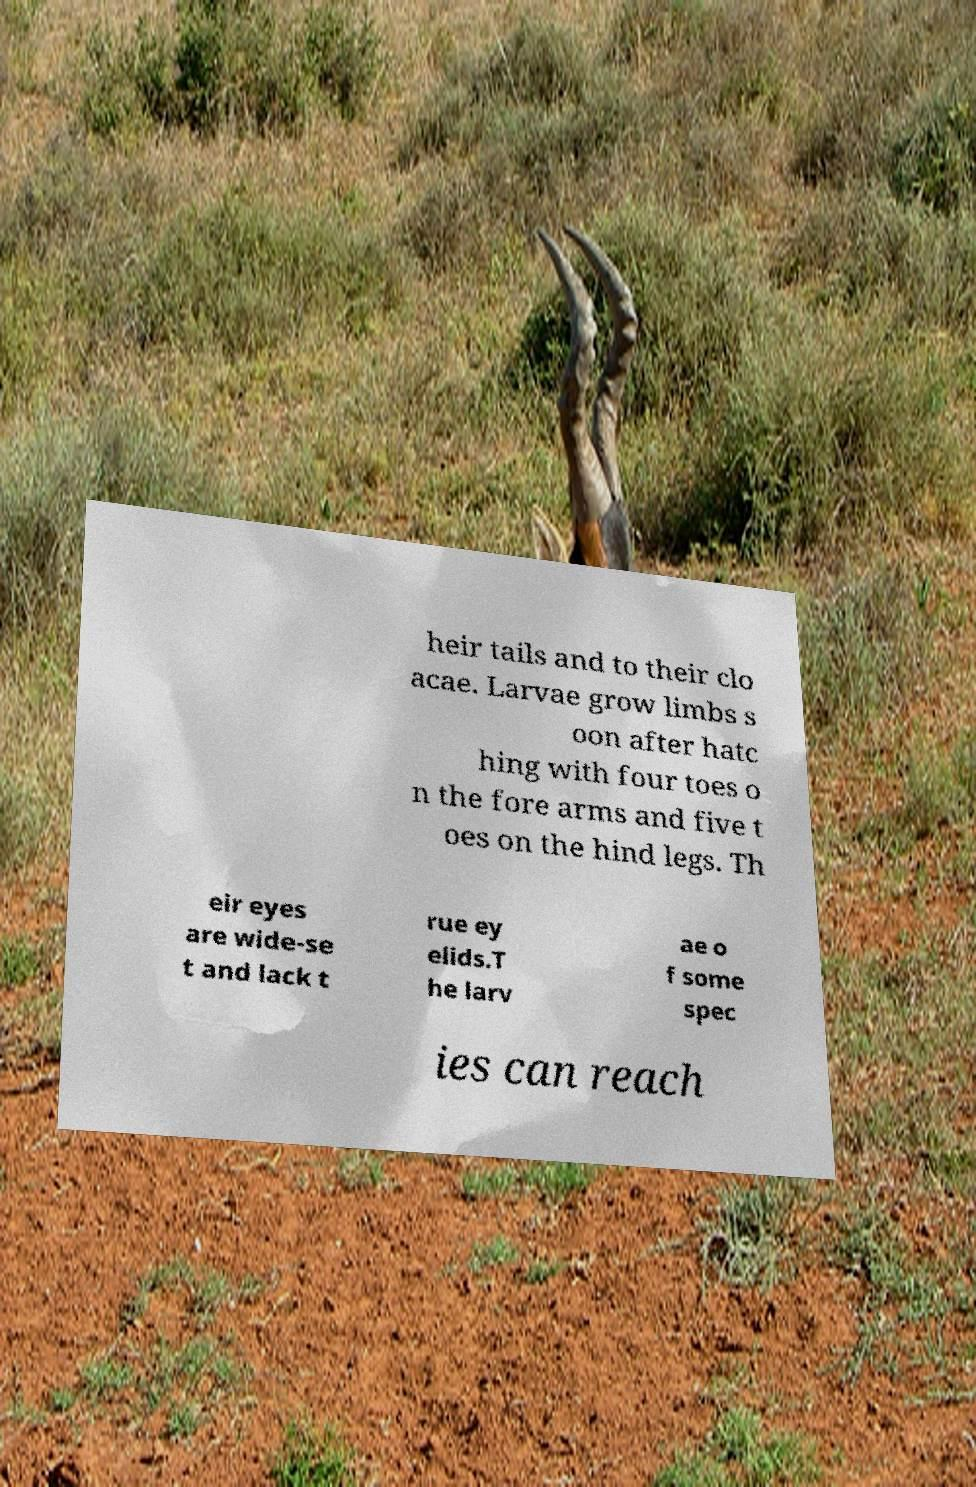What messages or text are displayed in this image? I need them in a readable, typed format. heir tails and to their clo acae. Larvae grow limbs s oon after hatc hing with four toes o n the fore arms and five t oes on the hind legs. Th eir eyes are wide-se t and lack t rue ey elids.T he larv ae o f some spec ies can reach 